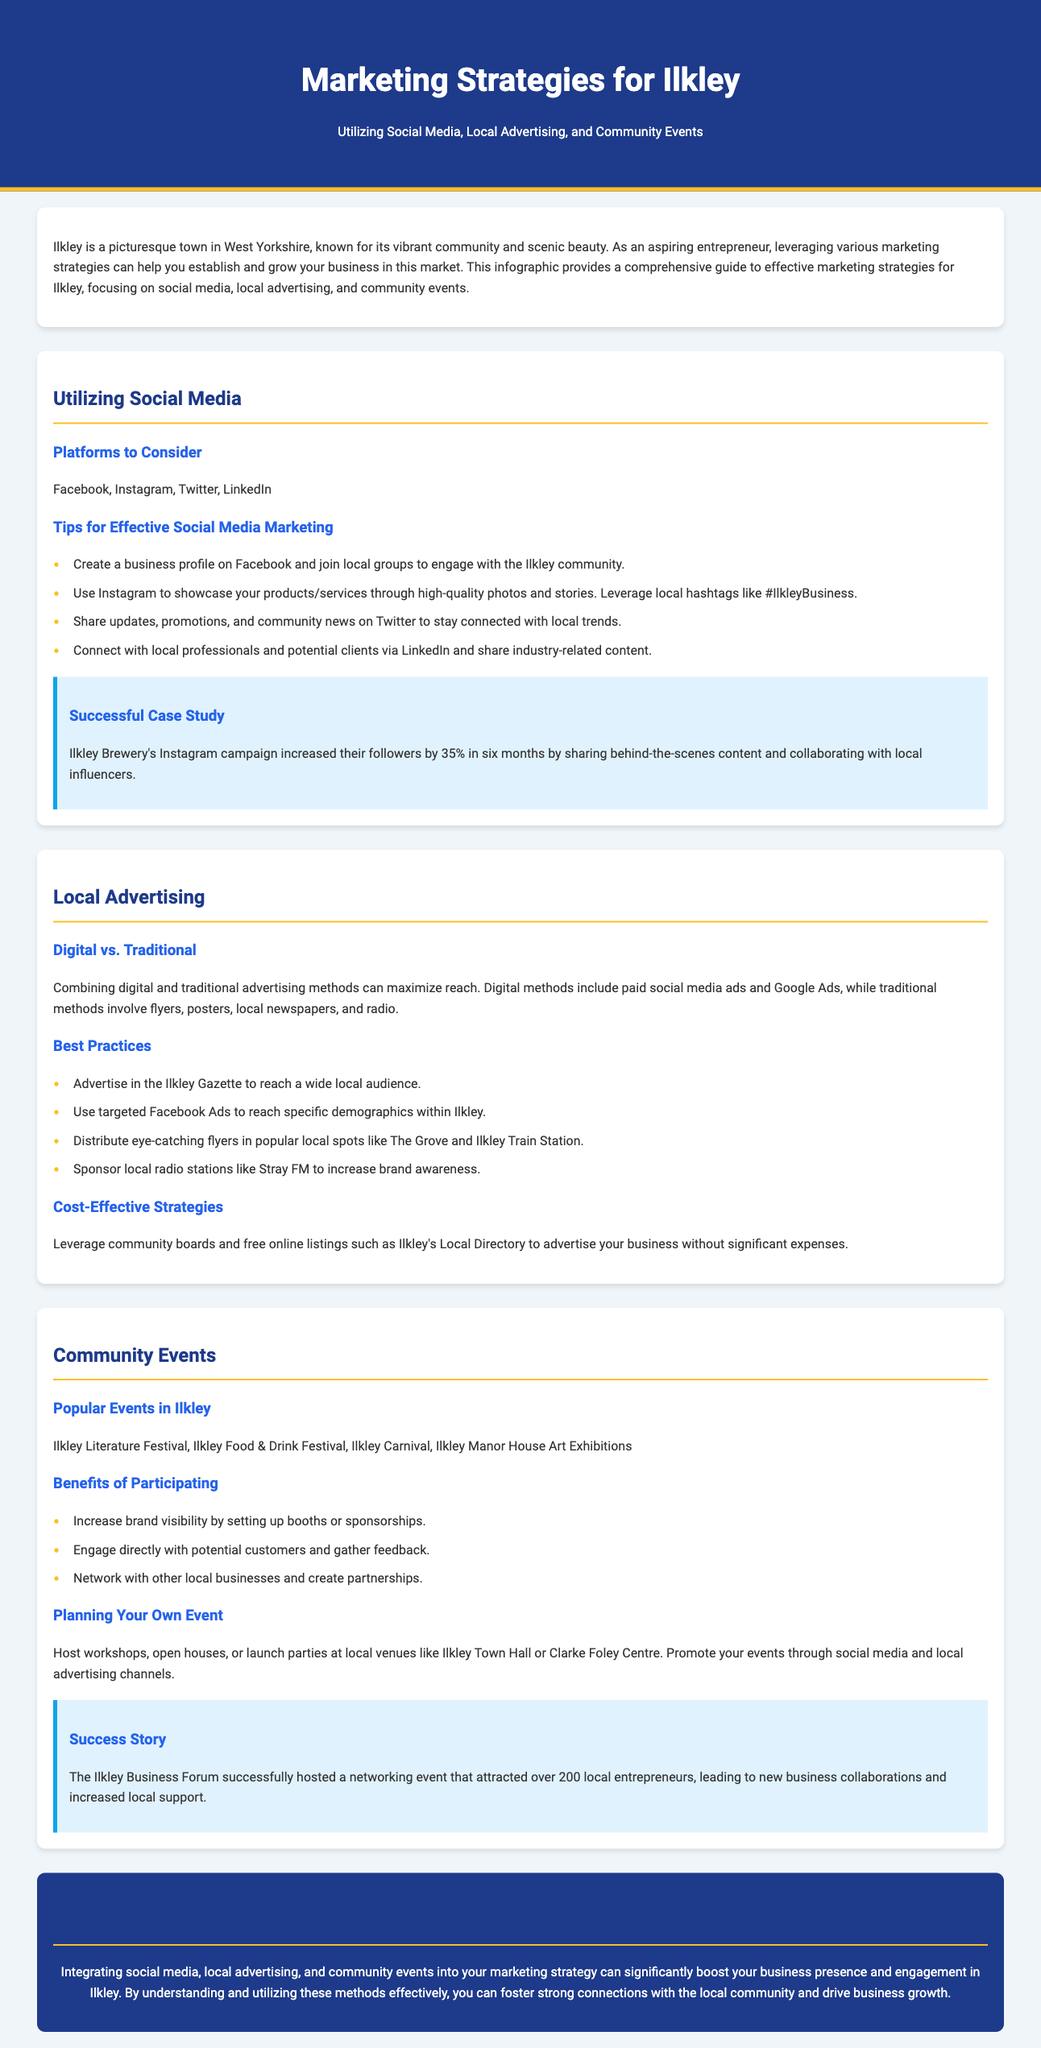What are the primary social media platforms to consider? The document lists Facebook, Instagram, Twitter, and LinkedIn as the primary social media platforms for marketing in Ilkley.
Answer: Facebook, Instagram, Twitter, LinkedIn What is a key tip for effective social media marketing? One of the tips provided is to use Instagram to showcase products/services through high-quality photos and stories.
Answer: Use Instagram for high-quality photos What local newspaper is suggested for advertising? The Ilkley Gazette is mentioned as a recommended local newspaper for advertising.
Answer: Ilkley Gazette What is a benefit of engaging in community events? Increasing brand visibility by setting up booths or sponsorships is highlighted as a key benefit of participating in community events.
Answer: Increase brand visibility How much did the Ilkley Brewery increase their followers by in six months? The case study shows that Ilkley Brewery's Instagram campaign increased their followers by 35%.
Answer: 35% What is the main conclusion drawn in the document? The conclusion emphasizes that integrating various marketing strategies can enhance business presence and engagement in Ilkley.
Answer: Boost business presence and engagement Which community event is listed as a popular option? The Ilkley Literature Festival is mentioned as one of the popular events in Ilkley.
Answer: Ilkley Literature Festival What is suggested as a cost-effective advertising strategy? Leveraging community boards and free online listings such as Ilkley's Local Directory is discussed as a cost-effective strategy.
Answer: Community boards and free online listings 